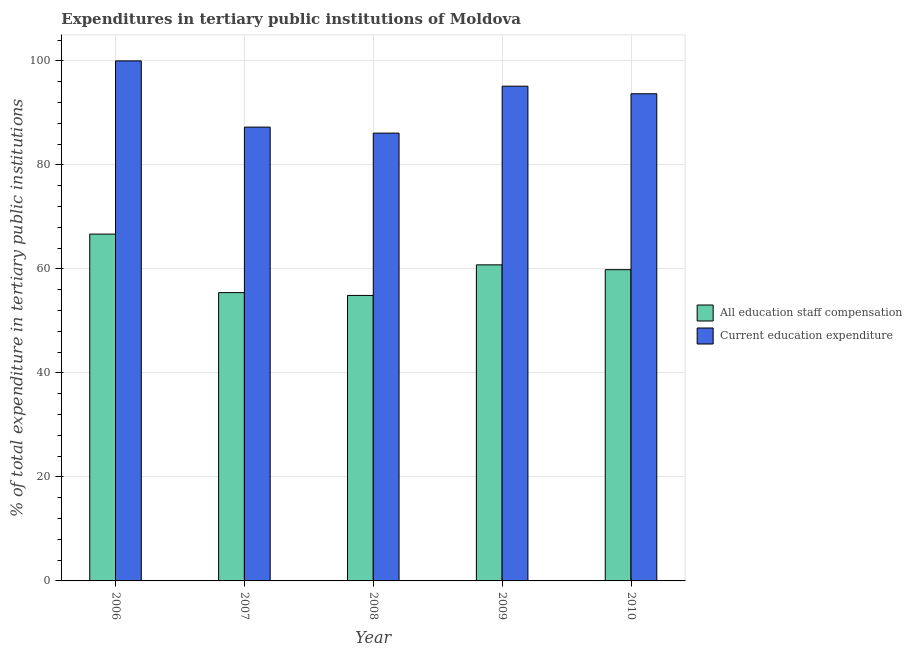How many groups of bars are there?
Give a very brief answer. 5. Are the number of bars per tick equal to the number of legend labels?
Keep it short and to the point. Yes. Are the number of bars on each tick of the X-axis equal?
Keep it short and to the point. Yes. How many bars are there on the 2nd tick from the right?
Provide a short and direct response. 2. What is the label of the 2nd group of bars from the left?
Ensure brevity in your answer.  2007. What is the expenditure in education in 2008?
Keep it short and to the point. 86.11. Across all years, what is the maximum expenditure in staff compensation?
Give a very brief answer. 66.69. Across all years, what is the minimum expenditure in education?
Your answer should be very brief. 86.11. In which year was the expenditure in staff compensation minimum?
Your answer should be very brief. 2008. What is the total expenditure in staff compensation in the graph?
Make the answer very short. 297.65. What is the difference between the expenditure in education in 2006 and that in 2010?
Ensure brevity in your answer.  6.32. What is the difference between the expenditure in staff compensation in 2006 and the expenditure in education in 2009?
Give a very brief answer. 5.92. What is the average expenditure in education per year?
Your response must be concise. 92.44. In the year 2009, what is the difference between the expenditure in staff compensation and expenditure in education?
Provide a short and direct response. 0. In how many years, is the expenditure in education greater than 68 %?
Your answer should be compact. 5. What is the ratio of the expenditure in education in 2007 to that in 2008?
Ensure brevity in your answer.  1.01. Is the expenditure in staff compensation in 2006 less than that in 2010?
Keep it short and to the point. No. Is the difference between the expenditure in staff compensation in 2008 and 2010 greater than the difference between the expenditure in education in 2008 and 2010?
Keep it short and to the point. No. What is the difference between the highest and the second highest expenditure in education?
Provide a succinct answer. 4.87. What is the difference between the highest and the lowest expenditure in staff compensation?
Give a very brief answer. 11.79. In how many years, is the expenditure in staff compensation greater than the average expenditure in staff compensation taken over all years?
Offer a very short reply. 3. Is the sum of the expenditure in education in 2008 and 2009 greater than the maximum expenditure in staff compensation across all years?
Offer a terse response. Yes. What does the 2nd bar from the left in 2010 represents?
Your answer should be very brief. Current education expenditure. What does the 1st bar from the right in 2006 represents?
Make the answer very short. Current education expenditure. How many bars are there?
Keep it short and to the point. 10. What is the difference between two consecutive major ticks on the Y-axis?
Your answer should be very brief. 20. Does the graph contain any zero values?
Your response must be concise. No. What is the title of the graph?
Make the answer very short. Expenditures in tertiary public institutions of Moldova. What is the label or title of the X-axis?
Provide a short and direct response. Year. What is the label or title of the Y-axis?
Provide a succinct answer. % of total expenditure in tertiary public institutions. What is the % of total expenditure in tertiary public institutions in All education staff compensation in 2006?
Offer a very short reply. 66.69. What is the % of total expenditure in tertiary public institutions in Current education expenditure in 2006?
Offer a terse response. 100. What is the % of total expenditure in tertiary public institutions in All education staff compensation in 2007?
Offer a terse response. 55.44. What is the % of total expenditure in tertiary public institutions of Current education expenditure in 2007?
Offer a terse response. 87.26. What is the % of total expenditure in tertiary public institutions in All education staff compensation in 2008?
Your answer should be very brief. 54.9. What is the % of total expenditure in tertiary public institutions in Current education expenditure in 2008?
Offer a very short reply. 86.11. What is the % of total expenditure in tertiary public institutions of All education staff compensation in 2009?
Ensure brevity in your answer.  60.78. What is the % of total expenditure in tertiary public institutions of Current education expenditure in 2009?
Your answer should be very brief. 95.13. What is the % of total expenditure in tertiary public institutions of All education staff compensation in 2010?
Your answer should be very brief. 59.85. What is the % of total expenditure in tertiary public institutions in Current education expenditure in 2010?
Give a very brief answer. 93.68. Across all years, what is the maximum % of total expenditure in tertiary public institutions of All education staff compensation?
Offer a very short reply. 66.69. Across all years, what is the maximum % of total expenditure in tertiary public institutions in Current education expenditure?
Provide a short and direct response. 100. Across all years, what is the minimum % of total expenditure in tertiary public institutions of All education staff compensation?
Your answer should be very brief. 54.9. Across all years, what is the minimum % of total expenditure in tertiary public institutions of Current education expenditure?
Make the answer very short. 86.11. What is the total % of total expenditure in tertiary public institutions in All education staff compensation in the graph?
Offer a very short reply. 297.65. What is the total % of total expenditure in tertiary public institutions of Current education expenditure in the graph?
Offer a terse response. 462.19. What is the difference between the % of total expenditure in tertiary public institutions of All education staff compensation in 2006 and that in 2007?
Your answer should be compact. 11.25. What is the difference between the % of total expenditure in tertiary public institutions of Current education expenditure in 2006 and that in 2007?
Make the answer very short. 12.74. What is the difference between the % of total expenditure in tertiary public institutions of All education staff compensation in 2006 and that in 2008?
Offer a terse response. 11.79. What is the difference between the % of total expenditure in tertiary public institutions in Current education expenditure in 2006 and that in 2008?
Provide a succinct answer. 13.89. What is the difference between the % of total expenditure in tertiary public institutions of All education staff compensation in 2006 and that in 2009?
Make the answer very short. 5.92. What is the difference between the % of total expenditure in tertiary public institutions in Current education expenditure in 2006 and that in 2009?
Give a very brief answer. 4.87. What is the difference between the % of total expenditure in tertiary public institutions in All education staff compensation in 2006 and that in 2010?
Your answer should be compact. 6.85. What is the difference between the % of total expenditure in tertiary public institutions of Current education expenditure in 2006 and that in 2010?
Make the answer very short. 6.32. What is the difference between the % of total expenditure in tertiary public institutions in All education staff compensation in 2007 and that in 2008?
Offer a terse response. 0.54. What is the difference between the % of total expenditure in tertiary public institutions of Current education expenditure in 2007 and that in 2008?
Your response must be concise. 1.15. What is the difference between the % of total expenditure in tertiary public institutions in All education staff compensation in 2007 and that in 2009?
Your answer should be compact. -5.34. What is the difference between the % of total expenditure in tertiary public institutions of Current education expenditure in 2007 and that in 2009?
Give a very brief answer. -7.87. What is the difference between the % of total expenditure in tertiary public institutions of All education staff compensation in 2007 and that in 2010?
Your answer should be compact. -4.41. What is the difference between the % of total expenditure in tertiary public institutions of Current education expenditure in 2007 and that in 2010?
Your answer should be very brief. -6.41. What is the difference between the % of total expenditure in tertiary public institutions of All education staff compensation in 2008 and that in 2009?
Provide a succinct answer. -5.88. What is the difference between the % of total expenditure in tertiary public institutions in Current education expenditure in 2008 and that in 2009?
Give a very brief answer. -9.03. What is the difference between the % of total expenditure in tertiary public institutions of All education staff compensation in 2008 and that in 2010?
Ensure brevity in your answer.  -4.95. What is the difference between the % of total expenditure in tertiary public institutions of Current education expenditure in 2008 and that in 2010?
Give a very brief answer. -7.57. What is the difference between the % of total expenditure in tertiary public institutions of All education staff compensation in 2009 and that in 2010?
Make the answer very short. 0.93. What is the difference between the % of total expenditure in tertiary public institutions in Current education expenditure in 2009 and that in 2010?
Keep it short and to the point. 1.46. What is the difference between the % of total expenditure in tertiary public institutions of All education staff compensation in 2006 and the % of total expenditure in tertiary public institutions of Current education expenditure in 2007?
Provide a succinct answer. -20.57. What is the difference between the % of total expenditure in tertiary public institutions in All education staff compensation in 2006 and the % of total expenditure in tertiary public institutions in Current education expenditure in 2008?
Make the answer very short. -19.42. What is the difference between the % of total expenditure in tertiary public institutions in All education staff compensation in 2006 and the % of total expenditure in tertiary public institutions in Current education expenditure in 2009?
Your response must be concise. -28.44. What is the difference between the % of total expenditure in tertiary public institutions in All education staff compensation in 2006 and the % of total expenditure in tertiary public institutions in Current education expenditure in 2010?
Give a very brief answer. -26.99. What is the difference between the % of total expenditure in tertiary public institutions of All education staff compensation in 2007 and the % of total expenditure in tertiary public institutions of Current education expenditure in 2008?
Offer a very short reply. -30.67. What is the difference between the % of total expenditure in tertiary public institutions in All education staff compensation in 2007 and the % of total expenditure in tertiary public institutions in Current education expenditure in 2009?
Give a very brief answer. -39.7. What is the difference between the % of total expenditure in tertiary public institutions of All education staff compensation in 2007 and the % of total expenditure in tertiary public institutions of Current education expenditure in 2010?
Keep it short and to the point. -38.24. What is the difference between the % of total expenditure in tertiary public institutions in All education staff compensation in 2008 and the % of total expenditure in tertiary public institutions in Current education expenditure in 2009?
Your response must be concise. -40.24. What is the difference between the % of total expenditure in tertiary public institutions of All education staff compensation in 2008 and the % of total expenditure in tertiary public institutions of Current education expenditure in 2010?
Give a very brief answer. -38.78. What is the difference between the % of total expenditure in tertiary public institutions in All education staff compensation in 2009 and the % of total expenditure in tertiary public institutions in Current education expenditure in 2010?
Offer a terse response. -32.9. What is the average % of total expenditure in tertiary public institutions of All education staff compensation per year?
Your answer should be compact. 59.53. What is the average % of total expenditure in tertiary public institutions in Current education expenditure per year?
Ensure brevity in your answer.  92.44. In the year 2006, what is the difference between the % of total expenditure in tertiary public institutions of All education staff compensation and % of total expenditure in tertiary public institutions of Current education expenditure?
Offer a very short reply. -33.31. In the year 2007, what is the difference between the % of total expenditure in tertiary public institutions of All education staff compensation and % of total expenditure in tertiary public institutions of Current education expenditure?
Your answer should be very brief. -31.83. In the year 2008, what is the difference between the % of total expenditure in tertiary public institutions in All education staff compensation and % of total expenditure in tertiary public institutions in Current education expenditure?
Ensure brevity in your answer.  -31.21. In the year 2009, what is the difference between the % of total expenditure in tertiary public institutions of All education staff compensation and % of total expenditure in tertiary public institutions of Current education expenditure?
Make the answer very short. -34.36. In the year 2010, what is the difference between the % of total expenditure in tertiary public institutions of All education staff compensation and % of total expenditure in tertiary public institutions of Current education expenditure?
Make the answer very short. -33.83. What is the ratio of the % of total expenditure in tertiary public institutions in All education staff compensation in 2006 to that in 2007?
Provide a short and direct response. 1.2. What is the ratio of the % of total expenditure in tertiary public institutions in Current education expenditure in 2006 to that in 2007?
Your answer should be compact. 1.15. What is the ratio of the % of total expenditure in tertiary public institutions of All education staff compensation in 2006 to that in 2008?
Give a very brief answer. 1.21. What is the ratio of the % of total expenditure in tertiary public institutions in Current education expenditure in 2006 to that in 2008?
Offer a very short reply. 1.16. What is the ratio of the % of total expenditure in tertiary public institutions in All education staff compensation in 2006 to that in 2009?
Offer a terse response. 1.1. What is the ratio of the % of total expenditure in tertiary public institutions of Current education expenditure in 2006 to that in 2009?
Make the answer very short. 1.05. What is the ratio of the % of total expenditure in tertiary public institutions of All education staff compensation in 2006 to that in 2010?
Provide a succinct answer. 1.11. What is the ratio of the % of total expenditure in tertiary public institutions in Current education expenditure in 2006 to that in 2010?
Your answer should be very brief. 1.07. What is the ratio of the % of total expenditure in tertiary public institutions in All education staff compensation in 2007 to that in 2008?
Provide a short and direct response. 1.01. What is the ratio of the % of total expenditure in tertiary public institutions of Current education expenditure in 2007 to that in 2008?
Ensure brevity in your answer.  1.01. What is the ratio of the % of total expenditure in tertiary public institutions of All education staff compensation in 2007 to that in 2009?
Offer a terse response. 0.91. What is the ratio of the % of total expenditure in tertiary public institutions in Current education expenditure in 2007 to that in 2009?
Ensure brevity in your answer.  0.92. What is the ratio of the % of total expenditure in tertiary public institutions in All education staff compensation in 2007 to that in 2010?
Provide a succinct answer. 0.93. What is the ratio of the % of total expenditure in tertiary public institutions in Current education expenditure in 2007 to that in 2010?
Make the answer very short. 0.93. What is the ratio of the % of total expenditure in tertiary public institutions of All education staff compensation in 2008 to that in 2009?
Provide a short and direct response. 0.9. What is the ratio of the % of total expenditure in tertiary public institutions in Current education expenditure in 2008 to that in 2009?
Keep it short and to the point. 0.91. What is the ratio of the % of total expenditure in tertiary public institutions of All education staff compensation in 2008 to that in 2010?
Ensure brevity in your answer.  0.92. What is the ratio of the % of total expenditure in tertiary public institutions of Current education expenditure in 2008 to that in 2010?
Ensure brevity in your answer.  0.92. What is the ratio of the % of total expenditure in tertiary public institutions in All education staff compensation in 2009 to that in 2010?
Provide a short and direct response. 1.02. What is the ratio of the % of total expenditure in tertiary public institutions of Current education expenditure in 2009 to that in 2010?
Ensure brevity in your answer.  1.02. What is the difference between the highest and the second highest % of total expenditure in tertiary public institutions of All education staff compensation?
Your answer should be very brief. 5.92. What is the difference between the highest and the second highest % of total expenditure in tertiary public institutions in Current education expenditure?
Give a very brief answer. 4.87. What is the difference between the highest and the lowest % of total expenditure in tertiary public institutions of All education staff compensation?
Your answer should be compact. 11.79. What is the difference between the highest and the lowest % of total expenditure in tertiary public institutions of Current education expenditure?
Ensure brevity in your answer.  13.89. 